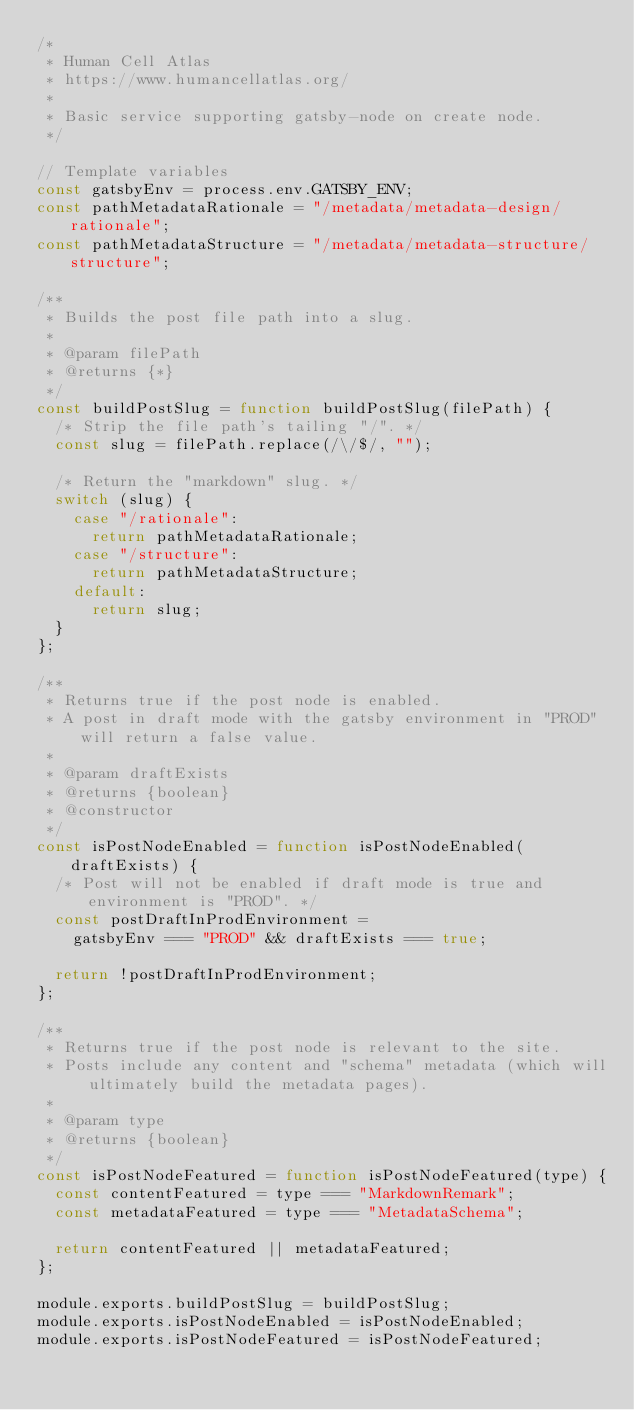Convert code to text. <code><loc_0><loc_0><loc_500><loc_500><_JavaScript_>/*
 * Human Cell Atlas
 * https://www.humancellatlas.org/
 *
 * Basic service supporting gatsby-node on create node.
 */

// Template variables
const gatsbyEnv = process.env.GATSBY_ENV;
const pathMetadataRationale = "/metadata/metadata-design/rationale";
const pathMetadataStructure = "/metadata/metadata-structure/structure";

/**
 * Builds the post file path into a slug.
 *
 * @param filePath
 * @returns {*}
 */
const buildPostSlug = function buildPostSlug(filePath) {
  /* Strip the file path's tailing "/". */
  const slug = filePath.replace(/\/$/, "");

  /* Return the "markdown" slug. */
  switch (slug) {
    case "/rationale":
      return pathMetadataRationale;
    case "/structure":
      return pathMetadataStructure;
    default:
      return slug;
  }
};

/**
 * Returns true if the post node is enabled.
 * A post in draft mode with the gatsby environment in "PROD" will return a false value.
 *
 * @param draftExists
 * @returns {boolean}
 * @constructor
 */
const isPostNodeEnabled = function isPostNodeEnabled(draftExists) {
  /* Post will not be enabled if draft mode is true and environment is "PROD". */
  const postDraftInProdEnvironment =
    gatsbyEnv === "PROD" && draftExists === true;

  return !postDraftInProdEnvironment;
};

/**
 * Returns true if the post node is relevant to the site.
 * Posts include any content and "schema" metadata (which will ultimately build the metadata pages).
 *
 * @param type
 * @returns {boolean}
 */
const isPostNodeFeatured = function isPostNodeFeatured(type) {
  const contentFeatured = type === "MarkdownRemark";
  const metadataFeatured = type === "MetadataSchema";

  return contentFeatured || metadataFeatured;
};

module.exports.buildPostSlug = buildPostSlug;
module.exports.isPostNodeEnabled = isPostNodeEnabled;
module.exports.isPostNodeFeatured = isPostNodeFeatured;
</code> 